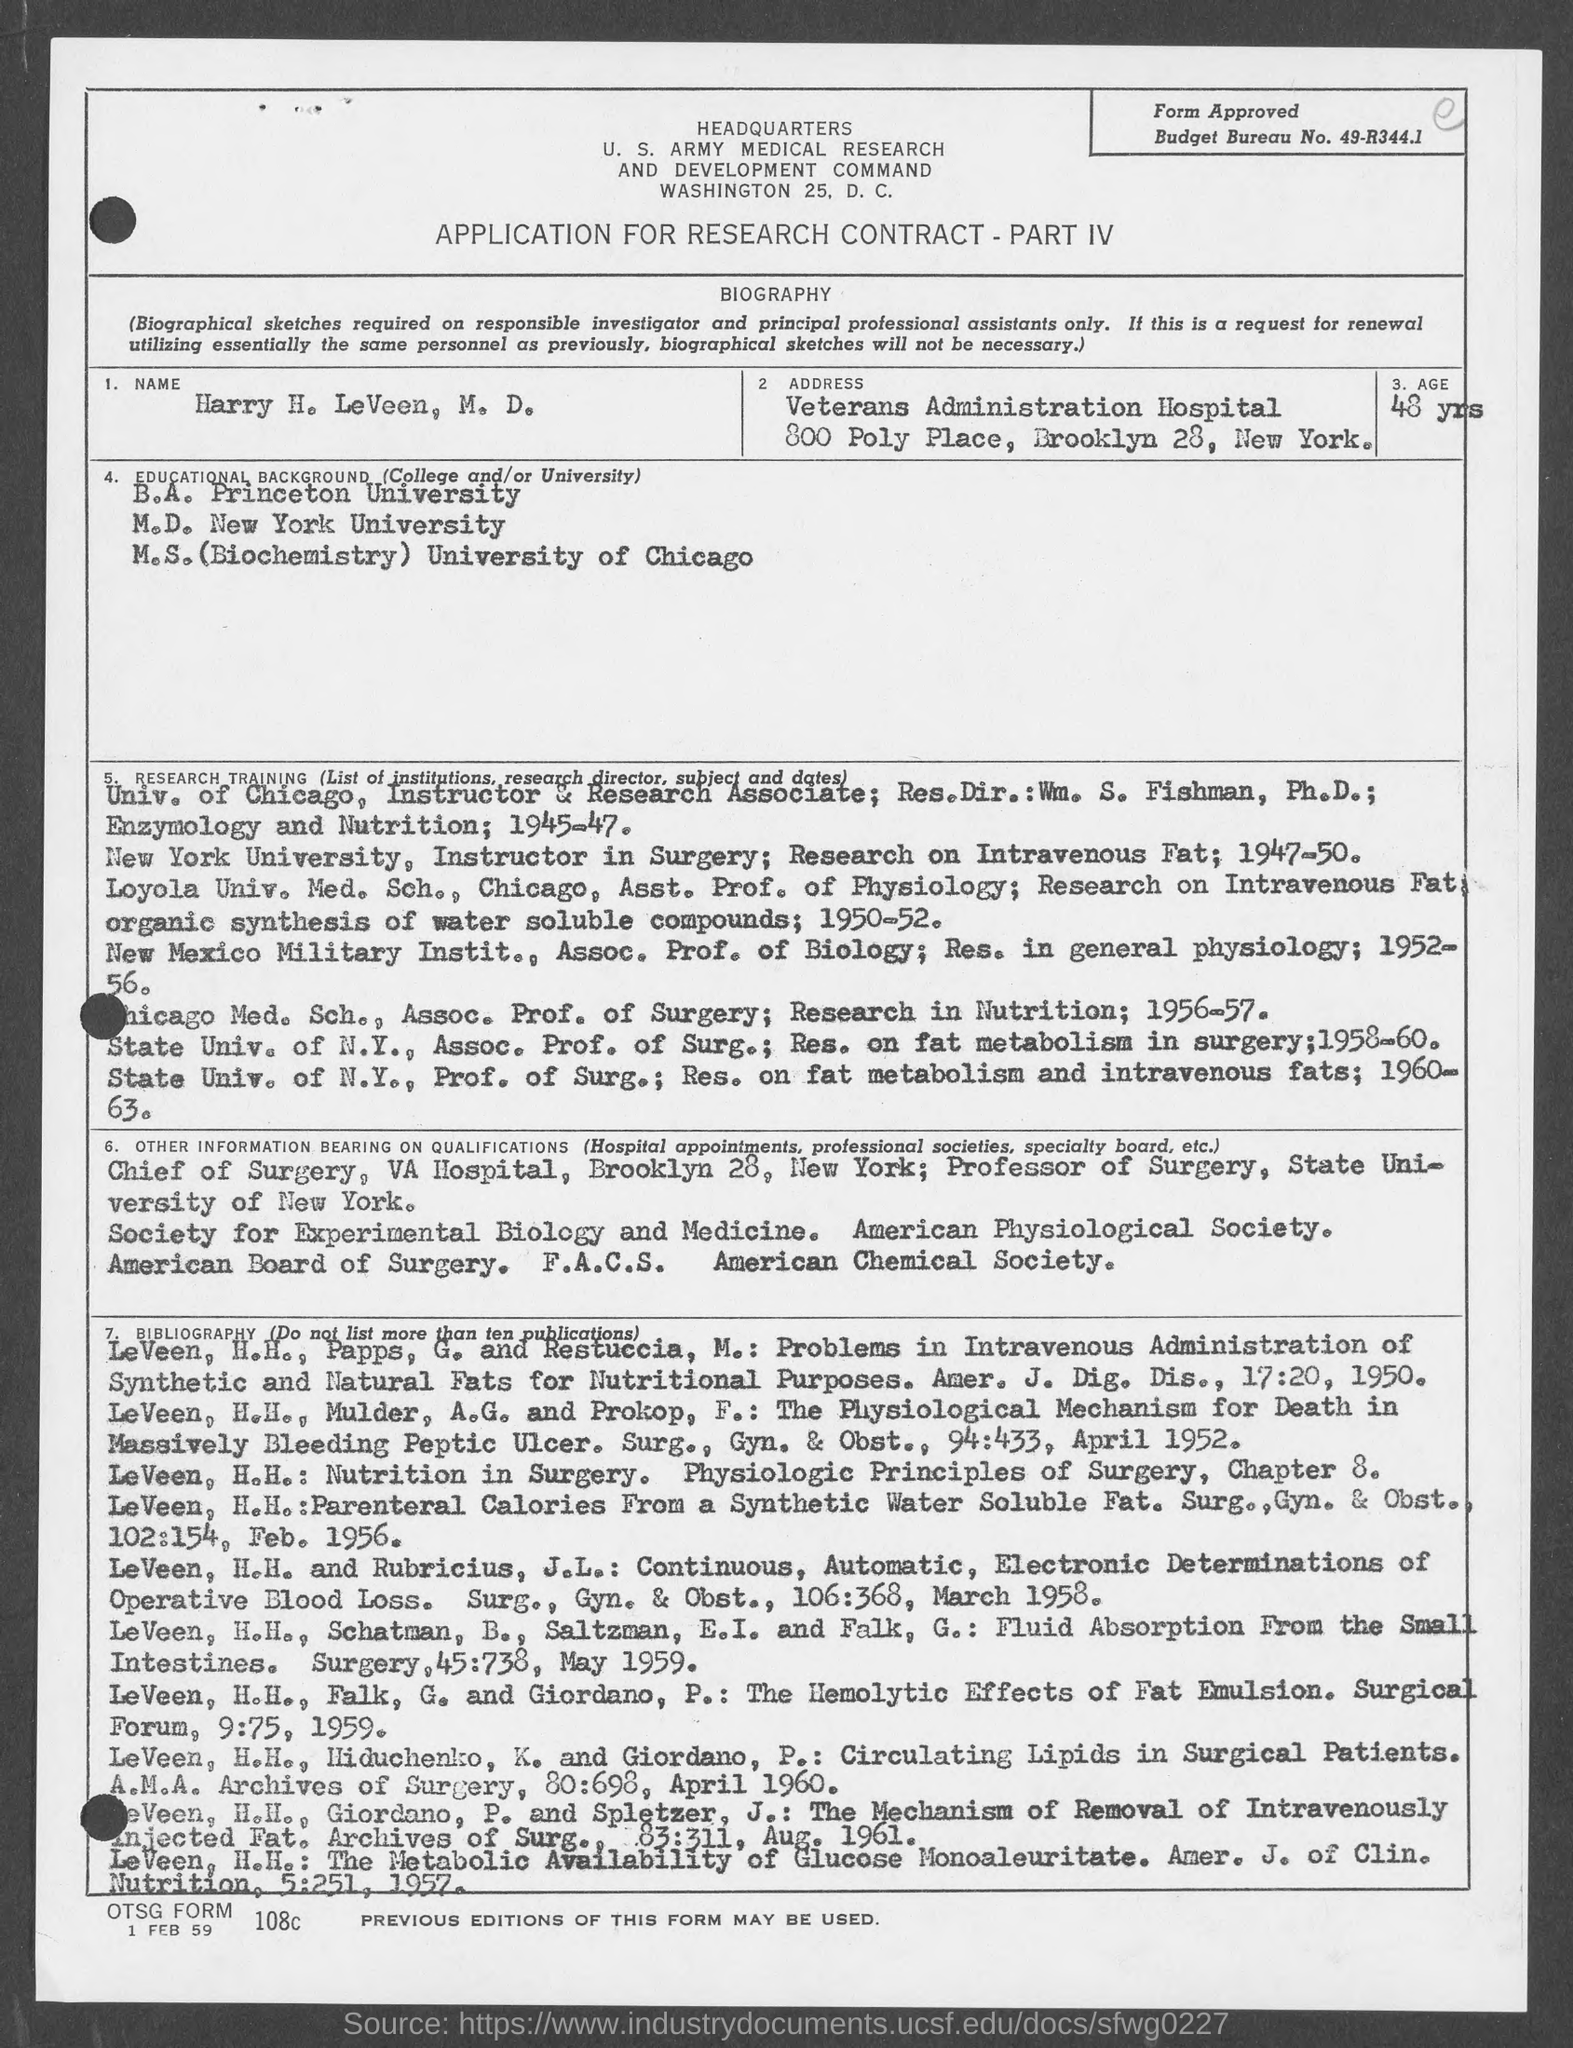Indicate a few pertinent items in this graphic. The individual completed their M.S. in biochemistry from the University of Chicago. I completed my Bachelor of Arts degree from Princeton University. M.D. was completed at New York University, which is the university from which it was obtained. The age mentioned in the given form is 48 years. The budget bureau number mentioned in the given form is 49-R344.1. 